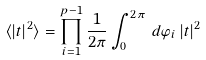<formula> <loc_0><loc_0><loc_500><loc_500>\langle | t | ^ { 2 } \rangle = \prod _ { i = 1 } ^ { p - 1 } \frac { 1 } { 2 \pi } \int _ { 0 } ^ { 2 \pi } \, d \varphi _ { i } \, | t | ^ { 2 }</formula> 